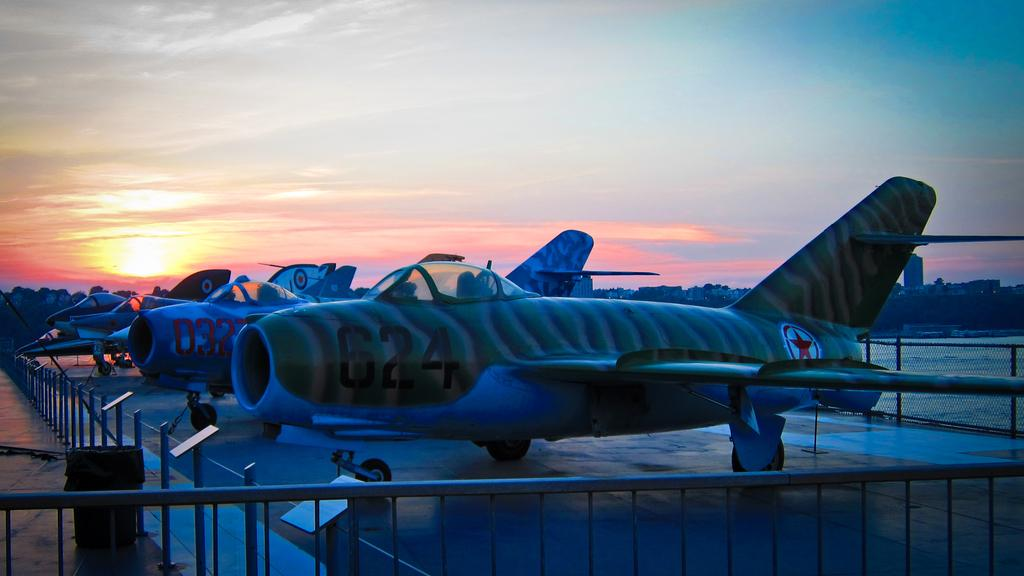<image>
Provide a brief description of the given image. A fighter jet with the number 624 on it is parked next to several other numbered aircraft. 